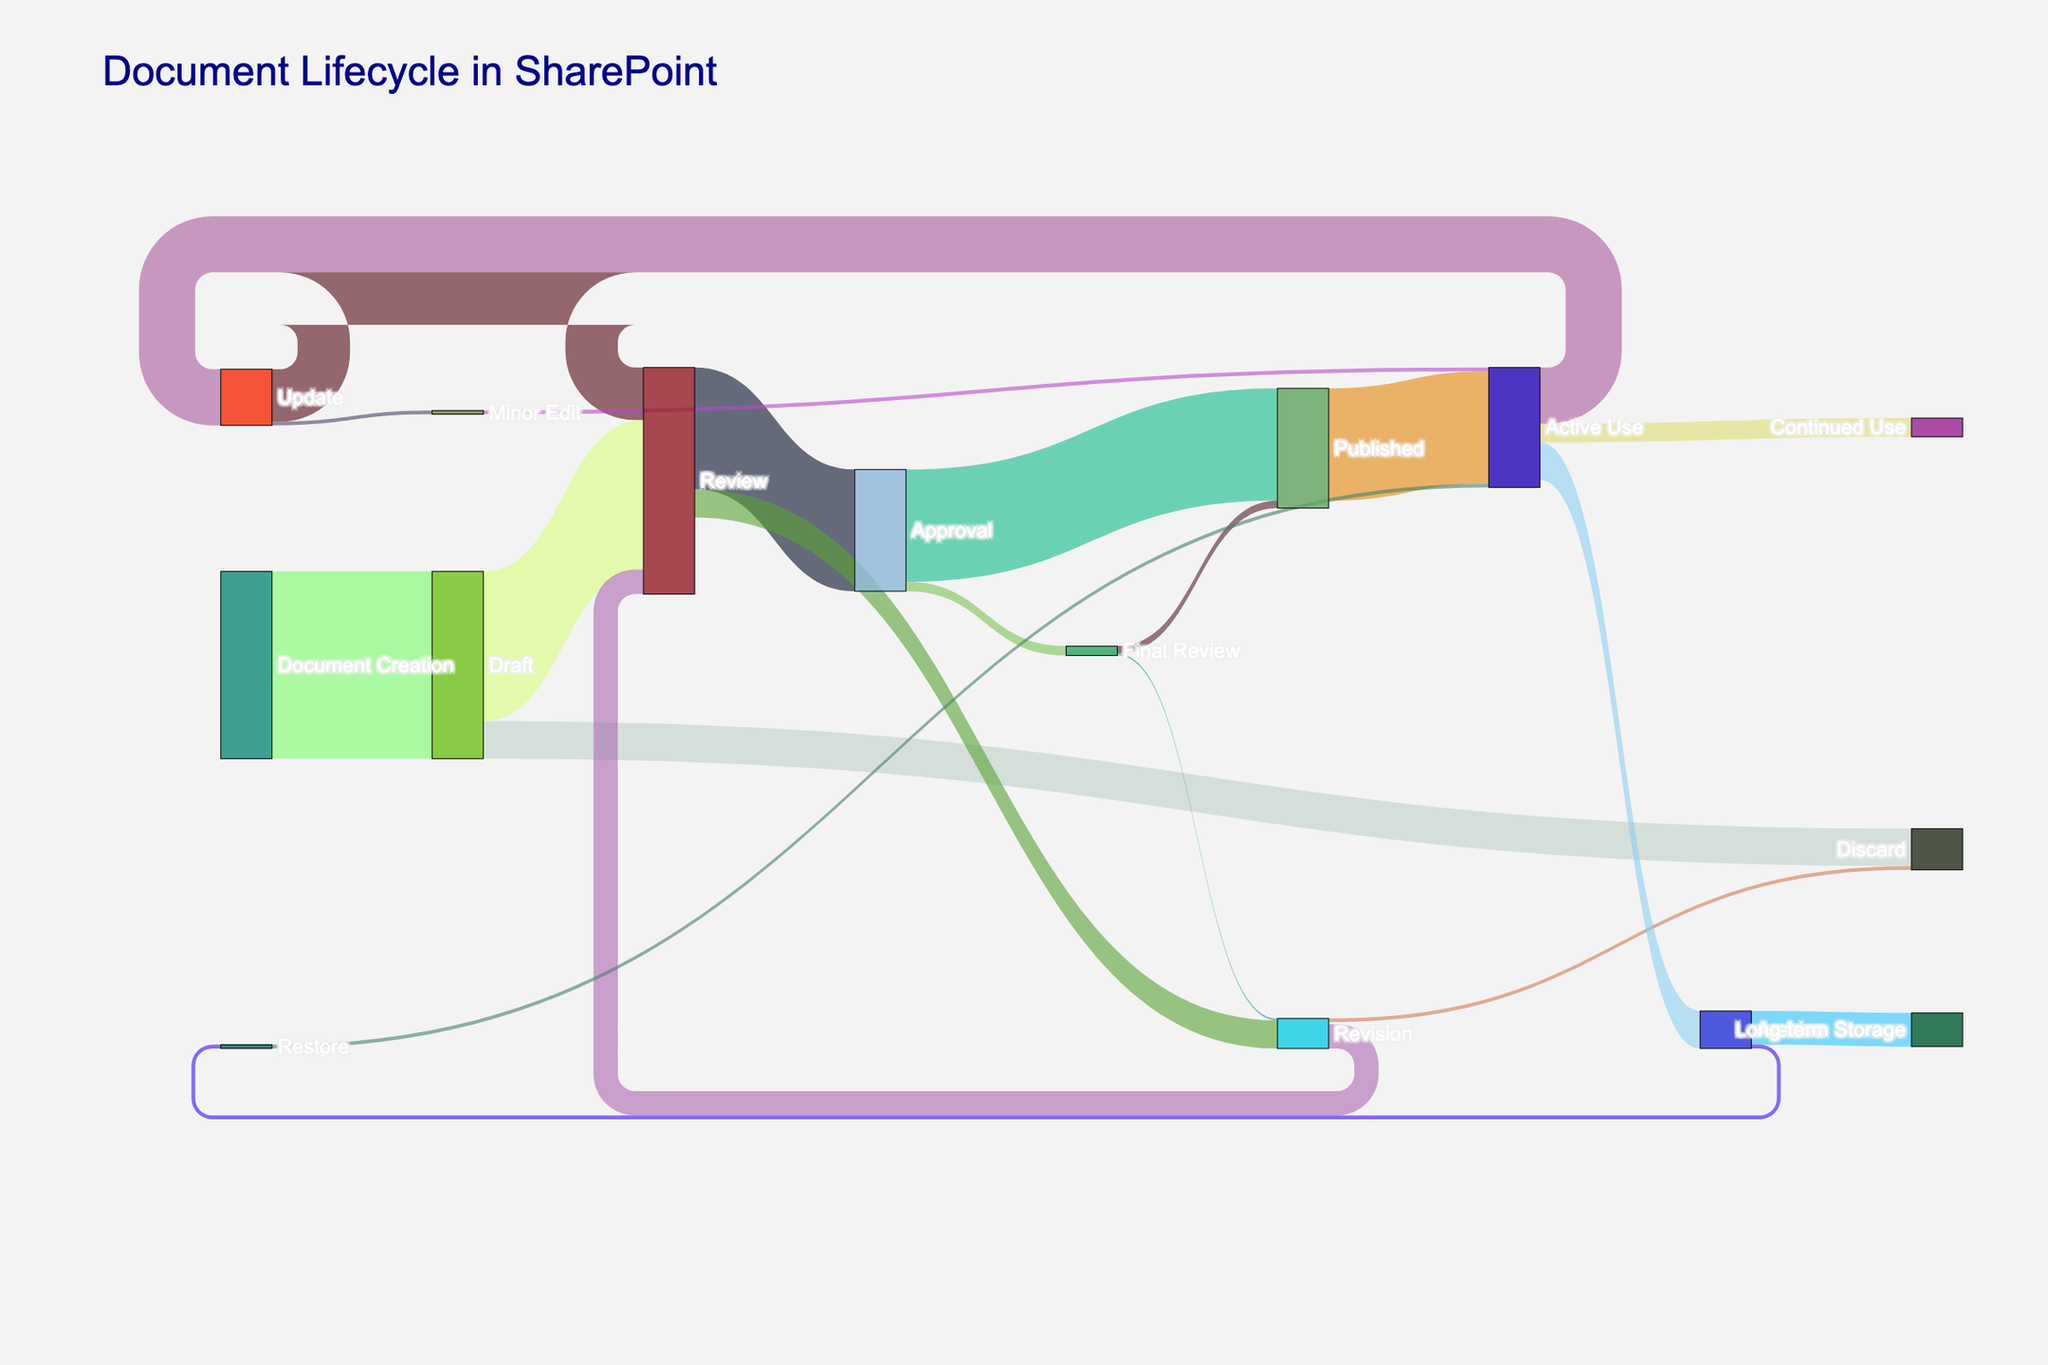What is the title of the figure? Look at the top of the Sankey diagram where the title is prominently displayed.
Answer: Document Lifecycle in SharePoint How many documents were initially created? Look for the starting point in the Sankey diagram, which shows the number of documents created.
Answer: 100 Which step has the highest number of documents getting discarded? Compare the values leading to "Discard" from different steps and identify the highest one.
Answer: Draft How many documents reach the "Final Review" stage from "Approval"? Trace the flow between the "Approval" and "Final Review" stages and read the value associated with it.
Answer: 5 How many documents undergo "Review" after being updated? Check the link connecting "Update" to "Review" and note the value.
Answer: 28 What is the total number of documents that get published eventually? Sum the values leading to "Published" from both "Approval" and "Final Review". That is, 60 (from Approval) + 4 (from Final Review).
Answer: 64 Which stage has the least interaction with documents? Identify the stage with the smallest cumulative value of incoming and outgoing flows.
Answer: Minor Edit How does the number of documents in "Active Use" compare to those in "Archive"? Check the values leading to "Active Use" compared to those leading to "Archive".
Answer: Active Use is higher How many documents are stored in "Long-term Storage"? Look for the value leading to "Long-term Storage" from "Archive".
Answer: 18 What is the final state of documents restored from the archive? Identify the link that connects "Restore" to its subsequent stage and note the value.
Answer: Active Use 